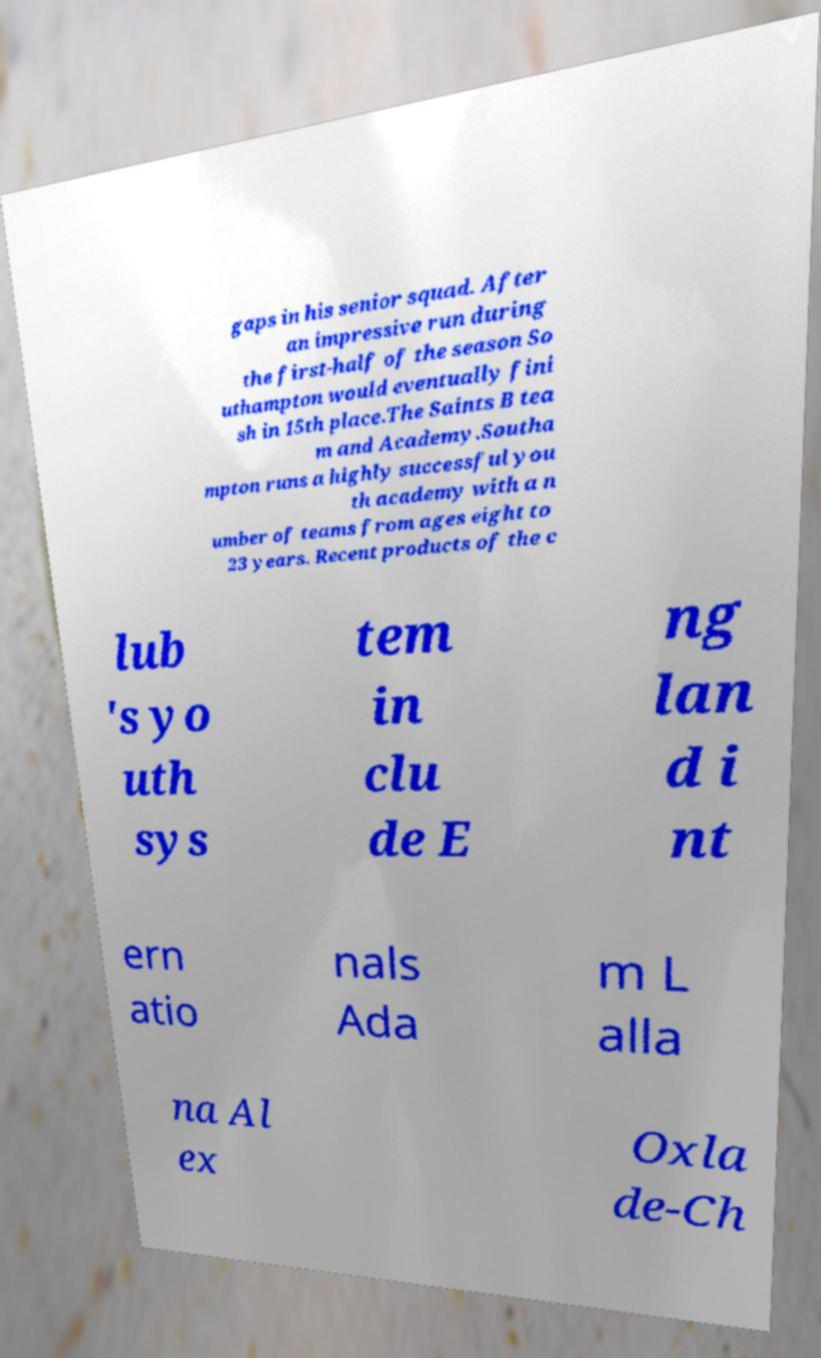Please read and relay the text visible in this image. What does it say? gaps in his senior squad. After an impressive run during the first-half of the season So uthampton would eventually fini sh in 15th place.The Saints B tea m and Academy.Southa mpton runs a highly successful you th academy with a n umber of teams from ages eight to 23 years. Recent products of the c lub 's yo uth sys tem in clu de E ng lan d i nt ern atio nals Ada m L alla na Al ex Oxla de-Ch 